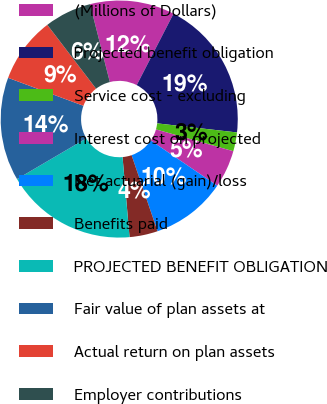<chart> <loc_0><loc_0><loc_500><loc_500><pie_chart><fcel>(Millions of Dollars)<fcel>Projected benefit obligation<fcel>Service cost - excluding<fcel>Interest cost on projected<fcel>Net actuarial (gain)/loss<fcel>Benefits paid<fcel>PROJECTED BENEFIT OBLIGATION<fcel>Fair value of plan assets at<fcel>Actual return on plan assets<fcel>Employer contributions<nl><fcel>11.54%<fcel>19.23%<fcel>2.57%<fcel>5.13%<fcel>10.26%<fcel>3.85%<fcel>17.94%<fcel>14.1%<fcel>8.97%<fcel>6.41%<nl></chart> 